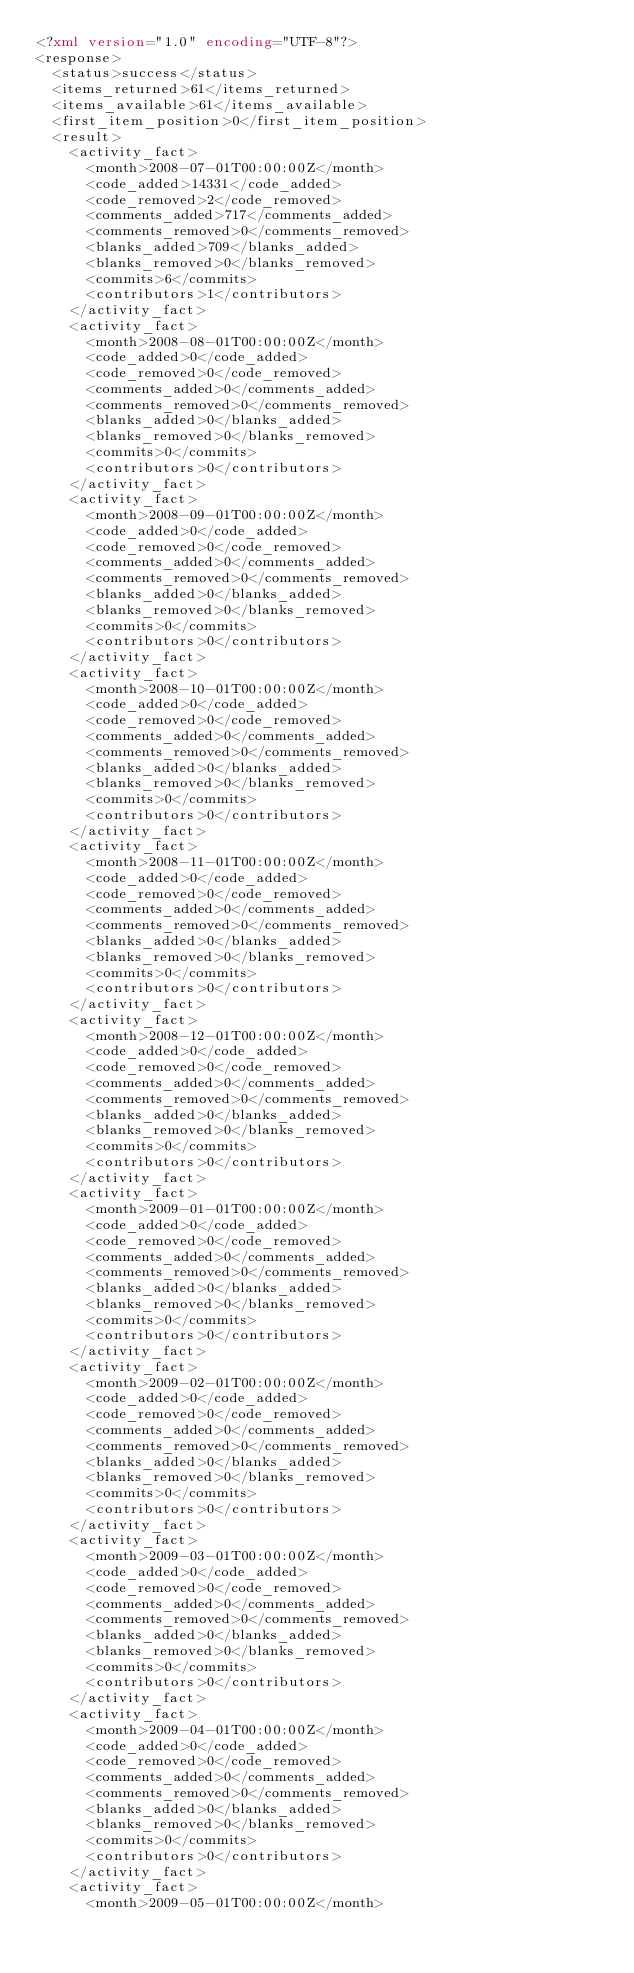Convert code to text. <code><loc_0><loc_0><loc_500><loc_500><_XML_><?xml version="1.0" encoding="UTF-8"?>
<response>
  <status>success</status>
  <items_returned>61</items_returned>
  <items_available>61</items_available>
  <first_item_position>0</first_item_position>
  <result>
    <activity_fact>
      <month>2008-07-01T00:00:00Z</month>
      <code_added>14331</code_added>
      <code_removed>2</code_removed>
      <comments_added>717</comments_added>
      <comments_removed>0</comments_removed>
      <blanks_added>709</blanks_added>
      <blanks_removed>0</blanks_removed>
      <commits>6</commits>
      <contributors>1</contributors>
    </activity_fact>
    <activity_fact>
      <month>2008-08-01T00:00:00Z</month>
      <code_added>0</code_added>
      <code_removed>0</code_removed>
      <comments_added>0</comments_added>
      <comments_removed>0</comments_removed>
      <blanks_added>0</blanks_added>
      <blanks_removed>0</blanks_removed>
      <commits>0</commits>
      <contributors>0</contributors>
    </activity_fact>
    <activity_fact>
      <month>2008-09-01T00:00:00Z</month>
      <code_added>0</code_added>
      <code_removed>0</code_removed>
      <comments_added>0</comments_added>
      <comments_removed>0</comments_removed>
      <blanks_added>0</blanks_added>
      <blanks_removed>0</blanks_removed>
      <commits>0</commits>
      <contributors>0</contributors>
    </activity_fact>
    <activity_fact>
      <month>2008-10-01T00:00:00Z</month>
      <code_added>0</code_added>
      <code_removed>0</code_removed>
      <comments_added>0</comments_added>
      <comments_removed>0</comments_removed>
      <blanks_added>0</blanks_added>
      <blanks_removed>0</blanks_removed>
      <commits>0</commits>
      <contributors>0</contributors>
    </activity_fact>
    <activity_fact>
      <month>2008-11-01T00:00:00Z</month>
      <code_added>0</code_added>
      <code_removed>0</code_removed>
      <comments_added>0</comments_added>
      <comments_removed>0</comments_removed>
      <blanks_added>0</blanks_added>
      <blanks_removed>0</blanks_removed>
      <commits>0</commits>
      <contributors>0</contributors>
    </activity_fact>
    <activity_fact>
      <month>2008-12-01T00:00:00Z</month>
      <code_added>0</code_added>
      <code_removed>0</code_removed>
      <comments_added>0</comments_added>
      <comments_removed>0</comments_removed>
      <blanks_added>0</blanks_added>
      <blanks_removed>0</blanks_removed>
      <commits>0</commits>
      <contributors>0</contributors>
    </activity_fact>
    <activity_fact>
      <month>2009-01-01T00:00:00Z</month>
      <code_added>0</code_added>
      <code_removed>0</code_removed>
      <comments_added>0</comments_added>
      <comments_removed>0</comments_removed>
      <blanks_added>0</blanks_added>
      <blanks_removed>0</blanks_removed>
      <commits>0</commits>
      <contributors>0</contributors>
    </activity_fact>
    <activity_fact>
      <month>2009-02-01T00:00:00Z</month>
      <code_added>0</code_added>
      <code_removed>0</code_removed>
      <comments_added>0</comments_added>
      <comments_removed>0</comments_removed>
      <blanks_added>0</blanks_added>
      <blanks_removed>0</blanks_removed>
      <commits>0</commits>
      <contributors>0</contributors>
    </activity_fact>
    <activity_fact>
      <month>2009-03-01T00:00:00Z</month>
      <code_added>0</code_added>
      <code_removed>0</code_removed>
      <comments_added>0</comments_added>
      <comments_removed>0</comments_removed>
      <blanks_added>0</blanks_added>
      <blanks_removed>0</blanks_removed>
      <commits>0</commits>
      <contributors>0</contributors>
    </activity_fact>
    <activity_fact>
      <month>2009-04-01T00:00:00Z</month>
      <code_added>0</code_added>
      <code_removed>0</code_removed>
      <comments_added>0</comments_added>
      <comments_removed>0</comments_removed>
      <blanks_added>0</blanks_added>
      <blanks_removed>0</blanks_removed>
      <commits>0</commits>
      <contributors>0</contributors>
    </activity_fact>
    <activity_fact>
      <month>2009-05-01T00:00:00Z</month></code> 